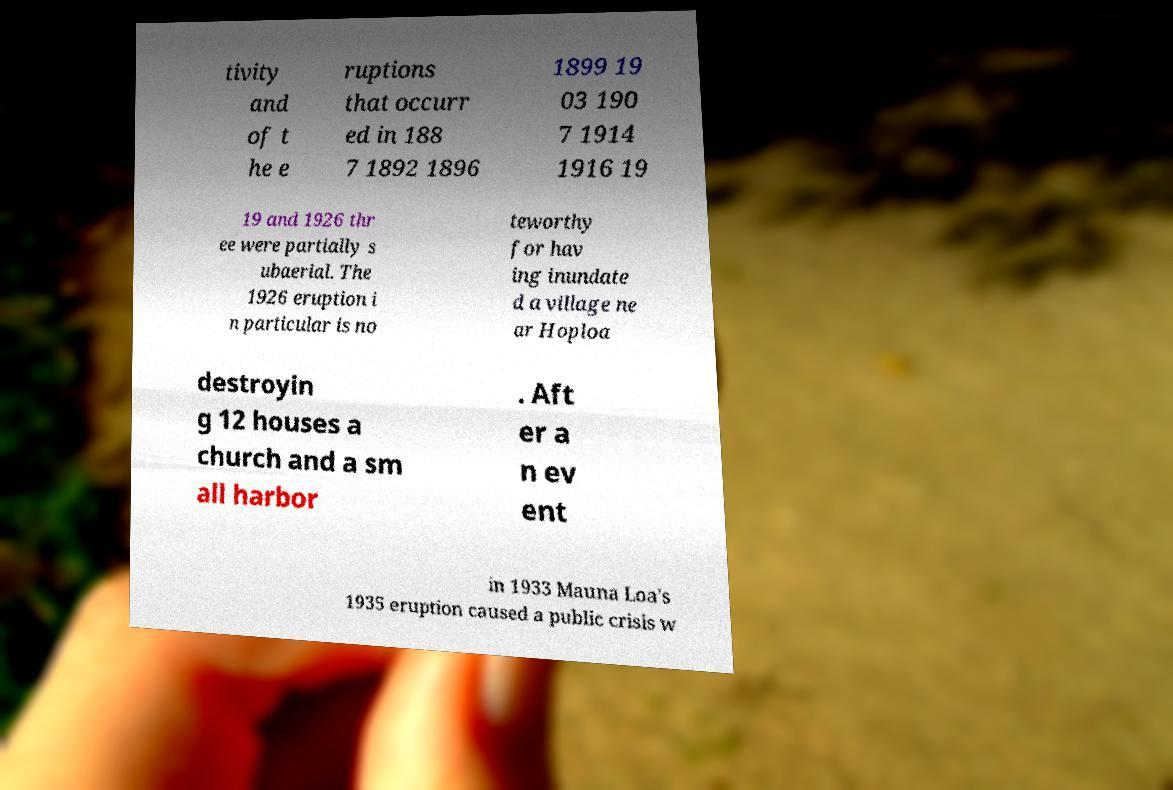For documentation purposes, I need the text within this image transcribed. Could you provide that? tivity and of t he e ruptions that occurr ed in 188 7 1892 1896 1899 19 03 190 7 1914 1916 19 19 and 1926 thr ee were partially s ubaerial. The 1926 eruption i n particular is no teworthy for hav ing inundate d a village ne ar Hoploa destroyin g 12 houses a church and a sm all harbor . Aft er a n ev ent in 1933 Mauna Loa's 1935 eruption caused a public crisis w 